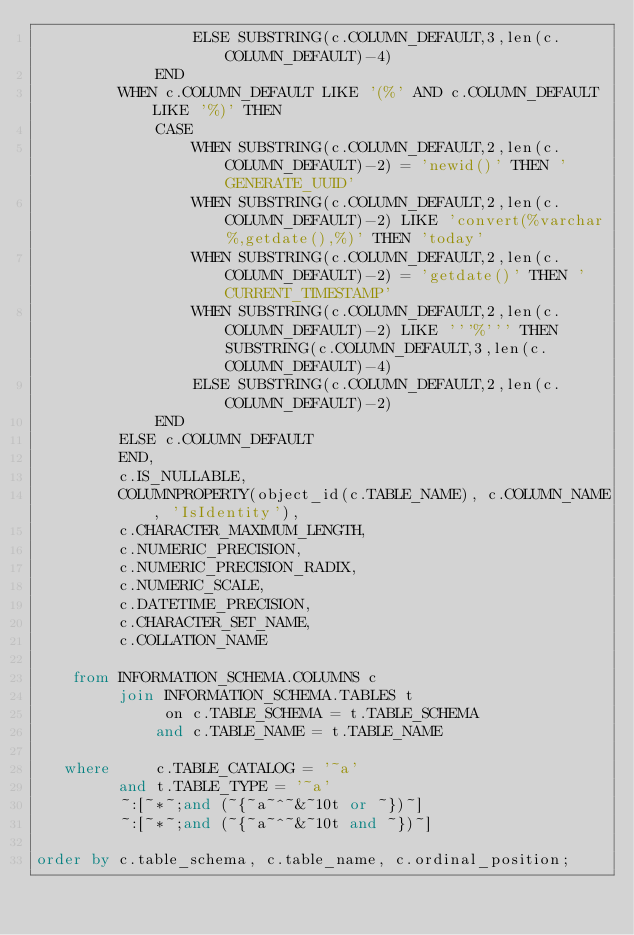<code> <loc_0><loc_0><loc_500><loc_500><_SQL_>                 ELSE SUBSTRING(c.COLUMN_DEFAULT,3,len(c.COLUMN_DEFAULT)-4)
             END
         WHEN c.COLUMN_DEFAULT LIKE '(%' AND c.COLUMN_DEFAULT LIKE '%)' THEN
             CASE
                 WHEN SUBSTRING(c.COLUMN_DEFAULT,2,len(c.COLUMN_DEFAULT)-2) = 'newid()' THEN 'GENERATE_UUID'
                 WHEN SUBSTRING(c.COLUMN_DEFAULT,2,len(c.COLUMN_DEFAULT)-2) LIKE 'convert(%varchar%,getdate(),%)' THEN 'today'
                 WHEN SUBSTRING(c.COLUMN_DEFAULT,2,len(c.COLUMN_DEFAULT)-2) = 'getdate()' THEN 'CURRENT_TIMESTAMP'
                 WHEN SUBSTRING(c.COLUMN_DEFAULT,2,len(c.COLUMN_DEFAULT)-2) LIKE '''%''' THEN SUBSTRING(c.COLUMN_DEFAULT,3,len(c.COLUMN_DEFAULT)-4)
                 ELSE SUBSTRING(c.COLUMN_DEFAULT,2,len(c.COLUMN_DEFAULT)-2)
             END
         ELSE c.COLUMN_DEFAULT
         END,
         c.IS_NULLABLE,
         COLUMNPROPERTY(object_id(c.TABLE_NAME), c.COLUMN_NAME, 'IsIdentity'),
         c.CHARACTER_MAXIMUM_LENGTH,
         c.NUMERIC_PRECISION,
         c.NUMERIC_PRECISION_RADIX,
         c.NUMERIC_SCALE,
         c.DATETIME_PRECISION,
         c.CHARACTER_SET_NAME,
         c.COLLATION_NAME

    from INFORMATION_SCHEMA.COLUMNS c
         join INFORMATION_SCHEMA.TABLES t
              on c.TABLE_SCHEMA = t.TABLE_SCHEMA
             and c.TABLE_NAME = t.TABLE_NAME

   where     c.TABLE_CATALOG = '~a'
         and t.TABLE_TYPE = '~a'
         ~:[~*~;and (~{~a~^~&~10t or ~})~]
         ~:[~*~;and (~{~a~^~&~10t and ~})~]

order by c.table_schema, c.table_name, c.ordinal_position;
</code> 